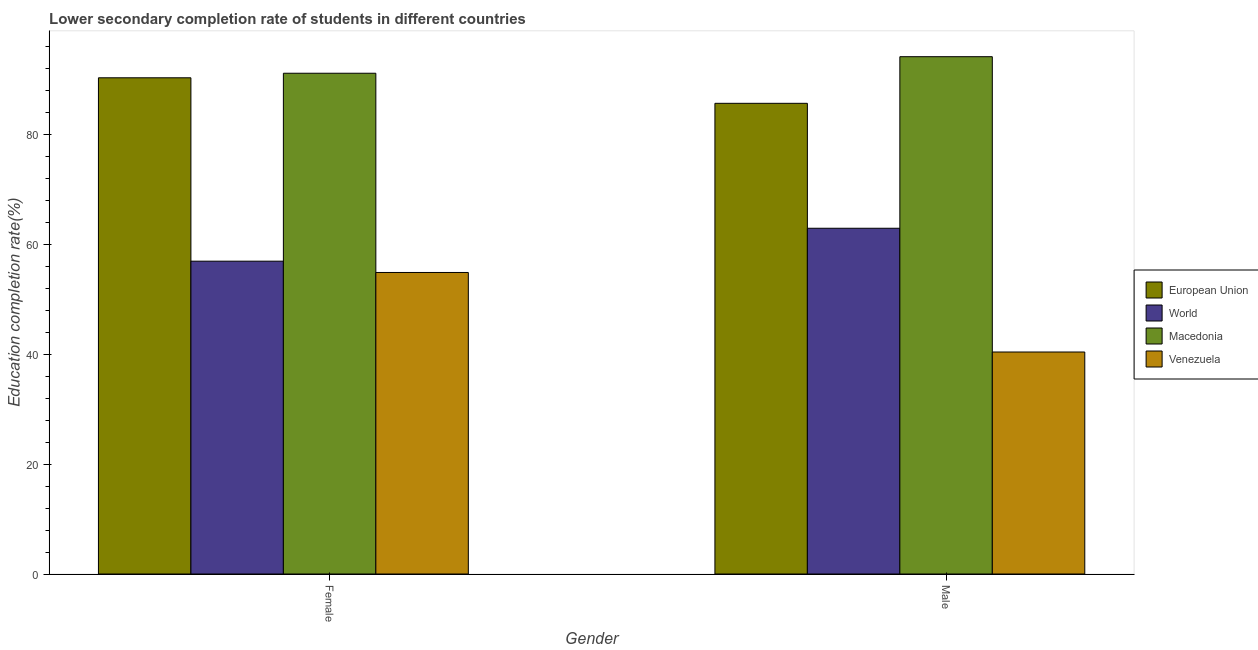How many different coloured bars are there?
Your answer should be very brief. 4. Are the number of bars per tick equal to the number of legend labels?
Offer a terse response. Yes. How many bars are there on the 1st tick from the right?
Your response must be concise. 4. What is the education completion rate of male students in Venezuela?
Provide a succinct answer. 40.41. Across all countries, what is the maximum education completion rate of male students?
Offer a terse response. 94.17. Across all countries, what is the minimum education completion rate of female students?
Your response must be concise. 54.89. In which country was the education completion rate of male students maximum?
Make the answer very short. Macedonia. In which country was the education completion rate of female students minimum?
Your answer should be compact. Venezuela. What is the total education completion rate of female students in the graph?
Your answer should be very brief. 293.33. What is the difference between the education completion rate of female students in Venezuela and that in European Union?
Ensure brevity in your answer.  -35.44. What is the difference between the education completion rate of male students in European Union and the education completion rate of female students in World?
Ensure brevity in your answer.  28.74. What is the average education completion rate of female students per country?
Make the answer very short. 73.33. What is the difference between the education completion rate of male students and education completion rate of female students in World?
Your response must be concise. 5.99. In how many countries, is the education completion rate of female students greater than 60 %?
Keep it short and to the point. 2. What is the ratio of the education completion rate of male students in Venezuela to that in European Union?
Give a very brief answer. 0.47. In how many countries, is the education completion rate of female students greater than the average education completion rate of female students taken over all countries?
Offer a very short reply. 2. What does the 3rd bar from the left in Female represents?
Your response must be concise. Macedonia. How many bars are there?
Your answer should be compact. 8. What is the difference between two consecutive major ticks on the Y-axis?
Your answer should be compact. 20. Are the values on the major ticks of Y-axis written in scientific E-notation?
Your answer should be very brief. No. Does the graph contain any zero values?
Provide a succinct answer. No. Does the graph contain grids?
Offer a very short reply. No. Where does the legend appear in the graph?
Give a very brief answer. Center right. How many legend labels are there?
Your answer should be compact. 4. What is the title of the graph?
Keep it short and to the point. Lower secondary completion rate of students in different countries. Does "Philippines" appear as one of the legend labels in the graph?
Offer a very short reply. No. What is the label or title of the X-axis?
Provide a short and direct response. Gender. What is the label or title of the Y-axis?
Your answer should be compact. Education completion rate(%). What is the Education completion rate(%) in European Union in Female?
Ensure brevity in your answer.  90.33. What is the Education completion rate(%) of World in Female?
Your response must be concise. 56.95. What is the Education completion rate(%) in Macedonia in Female?
Ensure brevity in your answer.  91.16. What is the Education completion rate(%) of Venezuela in Female?
Make the answer very short. 54.89. What is the Education completion rate(%) of European Union in Male?
Ensure brevity in your answer.  85.69. What is the Education completion rate(%) of World in Male?
Your response must be concise. 62.94. What is the Education completion rate(%) of Macedonia in Male?
Ensure brevity in your answer.  94.17. What is the Education completion rate(%) in Venezuela in Male?
Give a very brief answer. 40.41. Across all Gender, what is the maximum Education completion rate(%) in European Union?
Give a very brief answer. 90.33. Across all Gender, what is the maximum Education completion rate(%) in World?
Provide a succinct answer. 62.94. Across all Gender, what is the maximum Education completion rate(%) of Macedonia?
Offer a very short reply. 94.17. Across all Gender, what is the maximum Education completion rate(%) in Venezuela?
Ensure brevity in your answer.  54.89. Across all Gender, what is the minimum Education completion rate(%) of European Union?
Provide a short and direct response. 85.69. Across all Gender, what is the minimum Education completion rate(%) of World?
Ensure brevity in your answer.  56.95. Across all Gender, what is the minimum Education completion rate(%) in Macedonia?
Give a very brief answer. 91.16. Across all Gender, what is the minimum Education completion rate(%) in Venezuela?
Provide a succinct answer. 40.41. What is the total Education completion rate(%) in European Union in the graph?
Offer a terse response. 176.02. What is the total Education completion rate(%) in World in the graph?
Make the answer very short. 119.89. What is the total Education completion rate(%) in Macedonia in the graph?
Your answer should be compact. 185.33. What is the total Education completion rate(%) of Venezuela in the graph?
Keep it short and to the point. 95.3. What is the difference between the Education completion rate(%) in European Union in Female and that in Male?
Provide a short and direct response. 4.65. What is the difference between the Education completion rate(%) of World in Female and that in Male?
Offer a terse response. -5.99. What is the difference between the Education completion rate(%) in Macedonia in Female and that in Male?
Provide a succinct answer. -3.01. What is the difference between the Education completion rate(%) in Venezuela in Female and that in Male?
Provide a succinct answer. 14.48. What is the difference between the Education completion rate(%) of European Union in Female and the Education completion rate(%) of World in Male?
Give a very brief answer. 27.39. What is the difference between the Education completion rate(%) in European Union in Female and the Education completion rate(%) in Macedonia in Male?
Offer a terse response. -3.84. What is the difference between the Education completion rate(%) in European Union in Female and the Education completion rate(%) in Venezuela in Male?
Your answer should be very brief. 49.92. What is the difference between the Education completion rate(%) in World in Female and the Education completion rate(%) in Macedonia in Male?
Provide a succinct answer. -37.23. What is the difference between the Education completion rate(%) in World in Female and the Education completion rate(%) in Venezuela in Male?
Ensure brevity in your answer.  16.54. What is the difference between the Education completion rate(%) of Macedonia in Female and the Education completion rate(%) of Venezuela in Male?
Your answer should be compact. 50.75. What is the average Education completion rate(%) in European Union per Gender?
Your answer should be very brief. 88.01. What is the average Education completion rate(%) in World per Gender?
Provide a short and direct response. 59.94. What is the average Education completion rate(%) of Macedonia per Gender?
Give a very brief answer. 92.67. What is the average Education completion rate(%) of Venezuela per Gender?
Offer a very short reply. 47.65. What is the difference between the Education completion rate(%) in European Union and Education completion rate(%) in World in Female?
Your response must be concise. 33.38. What is the difference between the Education completion rate(%) in European Union and Education completion rate(%) in Macedonia in Female?
Provide a short and direct response. -0.83. What is the difference between the Education completion rate(%) of European Union and Education completion rate(%) of Venezuela in Female?
Provide a short and direct response. 35.44. What is the difference between the Education completion rate(%) of World and Education completion rate(%) of Macedonia in Female?
Provide a succinct answer. -34.21. What is the difference between the Education completion rate(%) in World and Education completion rate(%) in Venezuela in Female?
Make the answer very short. 2.06. What is the difference between the Education completion rate(%) in Macedonia and Education completion rate(%) in Venezuela in Female?
Keep it short and to the point. 36.27. What is the difference between the Education completion rate(%) in European Union and Education completion rate(%) in World in Male?
Give a very brief answer. 22.74. What is the difference between the Education completion rate(%) of European Union and Education completion rate(%) of Macedonia in Male?
Your answer should be very brief. -8.49. What is the difference between the Education completion rate(%) of European Union and Education completion rate(%) of Venezuela in Male?
Provide a short and direct response. 45.27. What is the difference between the Education completion rate(%) in World and Education completion rate(%) in Macedonia in Male?
Make the answer very short. -31.23. What is the difference between the Education completion rate(%) in World and Education completion rate(%) in Venezuela in Male?
Your answer should be very brief. 22.53. What is the difference between the Education completion rate(%) of Macedonia and Education completion rate(%) of Venezuela in Male?
Ensure brevity in your answer.  53.76. What is the ratio of the Education completion rate(%) of European Union in Female to that in Male?
Give a very brief answer. 1.05. What is the ratio of the Education completion rate(%) of World in Female to that in Male?
Give a very brief answer. 0.9. What is the ratio of the Education completion rate(%) of Venezuela in Female to that in Male?
Provide a short and direct response. 1.36. What is the difference between the highest and the second highest Education completion rate(%) of European Union?
Your answer should be very brief. 4.65. What is the difference between the highest and the second highest Education completion rate(%) in World?
Your answer should be compact. 5.99. What is the difference between the highest and the second highest Education completion rate(%) of Macedonia?
Give a very brief answer. 3.01. What is the difference between the highest and the second highest Education completion rate(%) in Venezuela?
Your response must be concise. 14.48. What is the difference between the highest and the lowest Education completion rate(%) in European Union?
Offer a very short reply. 4.65. What is the difference between the highest and the lowest Education completion rate(%) in World?
Make the answer very short. 5.99. What is the difference between the highest and the lowest Education completion rate(%) in Macedonia?
Make the answer very short. 3.01. What is the difference between the highest and the lowest Education completion rate(%) of Venezuela?
Provide a succinct answer. 14.48. 